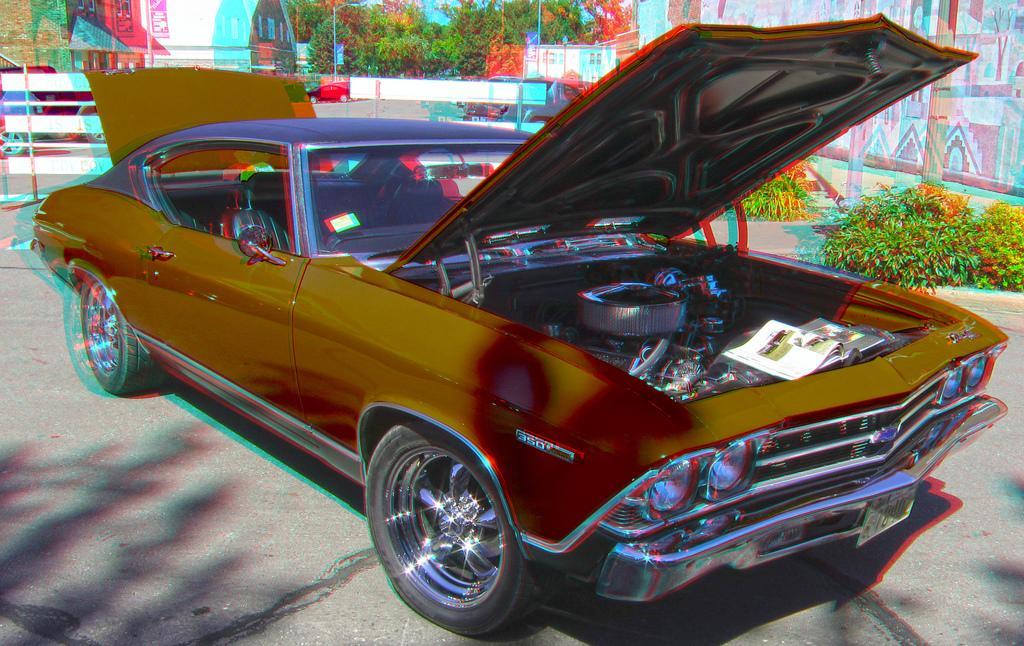Could you give a brief overview of what you see in this image? In this image we can see few vehicles. There are many trees and few plants in the image. There is a sky in the image. There is an object is placed on the car. There is a fencing and advertising board in the image. There is a pole at the right side of the image. There is a house in the image. 